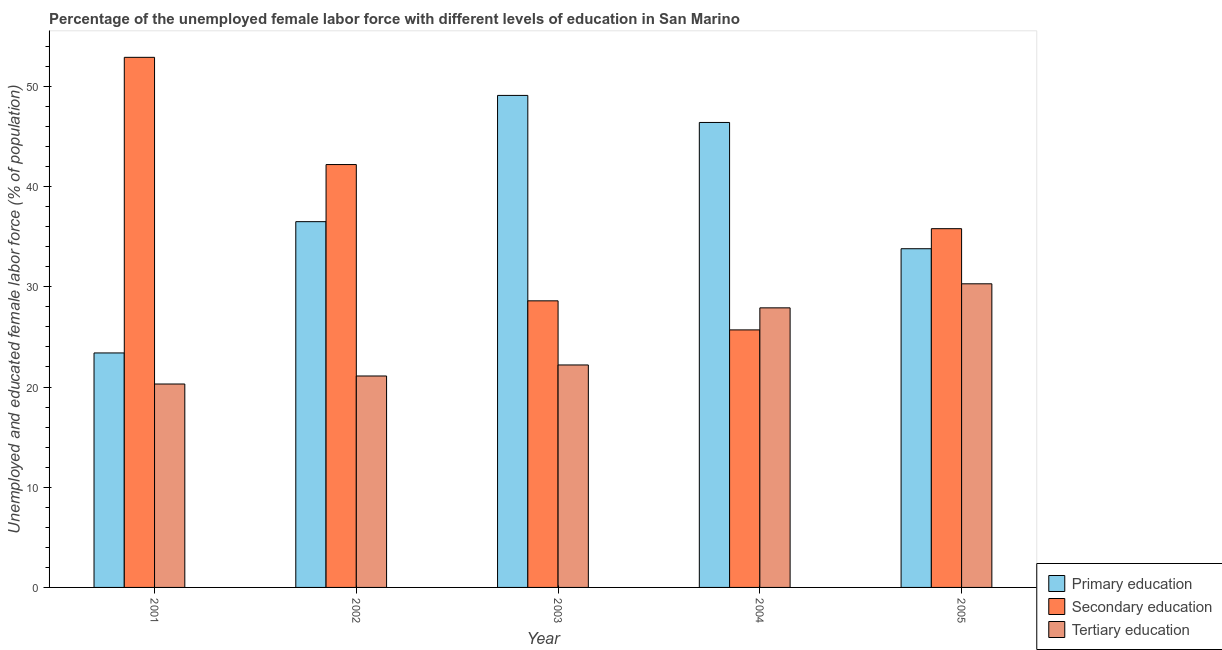How many different coloured bars are there?
Provide a short and direct response. 3. How many groups of bars are there?
Give a very brief answer. 5. Are the number of bars on each tick of the X-axis equal?
Provide a short and direct response. Yes. What is the percentage of female labor force who received tertiary education in 2001?
Keep it short and to the point. 20.3. Across all years, what is the maximum percentage of female labor force who received primary education?
Make the answer very short. 49.1. Across all years, what is the minimum percentage of female labor force who received secondary education?
Your response must be concise. 25.7. In which year was the percentage of female labor force who received tertiary education maximum?
Your response must be concise. 2005. What is the total percentage of female labor force who received primary education in the graph?
Make the answer very short. 189.2. What is the difference between the percentage of female labor force who received secondary education in 2002 and that in 2004?
Your answer should be very brief. 16.5. What is the difference between the percentage of female labor force who received secondary education in 2002 and the percentage of female labor force who received primary education in 2005?
Keep it short and to the point. 6.4. What is the average percentage of female labor force who received secondary education per year?
Offer a very short reply. 37.04. In the year 2002, what is the difference between the percentage of female labor force who received tertiary education and percentage of female labor force who received primary education?
Keep it short and to the point. 0. What is the ratio of the percentage of female labor force who received tertiary education in 2004 to that in 2005?
Offer a very short reply. 0.92. Is the percentage of female labor force who received secondary education in 2001 less than that in 2002?
Keep it short and to the point. No. Is the difference between the percentage of female labor force who received primary education in 2001 and 2003 greater than the difference between the percentage of female labor force who received tertiary education in 2001 and 2003?
Your answer should be very brief. No. What is the difference between the highest and the second highest percentage of female labor force who received tertiary education?
Keep it short and to the point. 2.4. What does the 2nd bar from the left in 2004 represents?
Make the answer very short. Secondary education. What does the 2nd bar from the right in 2004 represents?
Provide a succinct answer. Secondary education. How many bars are there?
Make the answer very short. 15. Are all the bars in the graph horizontal?
Your answer should be compact. No. How many years are there in the graph?
Offer a terse response. 5. What is the difference between two consecutive major ticks on the Y-axis?
Keep it short and to the point. 10. Are the values on the major ticks of Y-axis written in scientific E-notation?
Give a very brief answer. No. Does the graph contain any zero values?
Your answer should be very brief. No. Does the graph contain grids?
Offer a very short reply. No. How many legend labels are there?
Provide a succinct answer. 3. How are the legend labels stacked?
Your answer should be very brief. Vertical. What is the title of the graph?
Offer a very short reply. Percentage of the unemployed female labor force with different levels of education in San Marino. Does "Hydroelectric sources" appear as one of the legend labels in the graph?
Give a very brief answer. No. What is the label or title of the Y-axis?
Offer a very short reply. Unemployed and educated female labor force (% of population). What is the Unemployed and educated female labor force (% of population) of Primary education in 2001?
Provide a succinct answer. 23.4. What is the Unemployed and educated female labor force (% of population) in Secondary education in 2001?
Ensure brevity in your answer.  52.9. What is the Unemployed and educated female labor force (% of population) of Tertiary education in 2001?
Ensure brevity in your answer.  20.3. What is the Unemployed and educated female labor force (% of population) in Primary education in 2002?
Give a very brief answer. 36.5. What is the Unemployed and educated female labor force (% of population) of Secondary education in 2002?
Your response must be concise. 42.2. What is the Unemployed and educated female labor force (% of population) of Tertiary education in 2002?
Ensure brevity in your answer.  21.1. What is the Unemployed and educated female labor force (% of population) of Primary education in 2003?
Provide a succinct answer. 49.1. What is the Unemployed and educated female labor force (% of population) in Secondary education in 2003?
Your response must be concise. 28.6. What is the Unemployed and educated female labor force (% of population) of Tertiary education in 2003?
Provide a short and direct response. 22.2. What is the Unemployed and educated female labor force (% of population) of Primary education in 2004?
Your response must be concise. 46.4. What is the Unemployed and educated female labor force (% of population) in Secondary education in 2004?
Your response must be concise. 25.7. What is the Unemployed and educated female labor force (% of population) in Tertiary education in 2004?
Provide a succinct answer. 27.9. What is the Unemployed and educated female labor force (% of population) of Primary education in 2005?
Your response must be concise. 33.8. What is the Unemployed and educated female labor force (% of population) of Secondary education in 2005?
Offer a very short reply. 35.8. What is the Unemployed and educated female labor force (% of population) of Tertiary education in 2005?
Your response must be concise. 30.3. Across all years, what is the maximum Unemployed and educated female labor force (% of population) in Primary education?
Make the answer very short. 49.1. Across all years, what is the maximum Unemployed and educated female labor force (% of population) in Secondary education?
Provide a succinct answer. 52.9. Across all years, what is the maximum Unemployed and educated female labor force (% of population) of Tertiary education?
Ensure brevity in your answer.  30.3. Across all years, what is the minimum Unemployed and educated female labor force (% of population) in Primary education?
Offer a very short reply. 23.4. Across all years, what is the minimum Unemployed and educated female labor force (% of population) of Secondary education?
Ensure brevity in your answer.  25.7. Across all years, what is the minimum Unemployed and educated female labor force (% of population) in Tertiary education?
Offer a terse response. 20.3. What is the total Unemployed and educated female labor force (% of population) of Primary education in the graph?
Your answer should be compact. 189.2. What is the total Unemployed and educated female labor force (% of population) of Secondary education in the graph?
Keep it short and to the point. 185.2. What is the total Unemployed and educated female labor force (% of population) in Tertiary education in the graph?
Provide a succinct answer. 121.8. What is the difference between the Unemployed and educated female labor force (% of population) in Primary education in 2001 and that in 2003?
Your response must be concise. -25.7. What is the difference between the Unemployed and educated female labor force (% of population) in Secondary education in 2001 and that in 2003?
Give a very brief answer. 24.3. What is the difference between the Unemployed and educated female labor force (% of population) in Secondary education in 2001 and that in 2004?
Your answer should be very brief. 27.2. What is the difference between the Unemployed and educated female labor force (% of population) of Tertiary education in 2001 and that in 2004?
Provide a succinct answer. -7.6. What is the difference between the Unemployed and educated female labor force (% of population) in Primary education in 2001 and that in 2005?
Provide a succinct answer. -10.4. What is the difference between the Unemployed and educated female labor force (% of population) in Tertiary education in 2002 and that in 2003?
Provide a succinct answer. -1.1. What is the difference between the Unemployed and educated female labor force (% of population) in Primary education in 2002 and that in 2004?
Make the answer very short. -9.9. What is the difference between the Unemployed and educated female labor force (% of population) in Secondary education in 2002 and that in 2004?
Provide a short and direct response. 16.5. What is the difference between the Unemployed and educated female labor force (% of population) of Primary education in 2002 and that in 2005?
Ensure brevity in your answer.  2.7. What is the difference between the Unemployed and educated female labor force (% of population) in Secondary education in 2002 and that in 2005?
Provide a short and direct response. 6.4. What is the difference between the Unemployed and educated female labor force (% of population) of Tertiary education in 2002 and that in 2005?
Make the answer very short. -9.2. What is the difference between the Unemployed and educated female labor force (% of population) in Primary education in 2003 and that in 2004?
Keep it short and to the point. 2.7. What is the difference between the Unemployed and educated female labor force (% of population) of Tertiary education in 2003 and that in 2004?
Offer a terse response. -5.7. What is the difference between the Unemployed and educated female labor force (% of population) in Primary education in 2003 and that in 2005?
Your response must be concise. 15.3. What is the difference between the Unemployed and educated female labor force (% of population) of Tertiary education in 2004 and that in 2005?
Your response must be concise. -2.4. What is the difference between the Unemployed and educated female labor force (% of population) of Primary education in 2001 and the Unemployed and educated female labor force (% of population) of Secondary education in 2002?
Your answer should be compact. -18.8. What is the difference between the Unemployed and educated female labor force (% of population) of Secondary education in 2001 and the Unemployed and educated female labor force (% of population) of Tertiary education in 2002?
Provide a short and direct response. 31.8. What is the difference between the Unemployed and educated female labor force (% of population) in Primary education in 2001 and the Unemployed and educated female labor force (% of population) in Secondary education in 2003?
Your answer should be very brief. -5.2. What is the difference between the Unemployed and educated female labor force (% of population) of Secondary education in 2001 and the Unemployed and educated female labor force (% of population) of Tertiary education in 2003?
Ensure brevity in your answer.  30.7. What is the difference between the Unemployed and educated female labor force (% of population) in Primary education in 2001 and the Unemployed and educated female labor force (% of population) in Secondary education in 2005?
Ensure brevity in your answer.  -12.4. What is the difference between the Unemployed and educated female labor force (% of population) in Secondary education in 2001 and the Unemployed and educated female labor force (% of population) in Tertiary education in 2005?
Your answer should be very brief. 22.6. What is the difference between the Unemployed and educated female labor force (% of population) of Primary education in 2002 and the Unemployed and educated female labor force (% of population) of Tertiary education in 2004?
Your response must be concise. 8.6. What is the difference between the Unemployed and educated female labor force (% of population) of Secondary education in 2002 and the Unemployed and educated female labor force (% of population) of Tertiary education in 2004?
Your answer should be compact. 14.3. What is the difference between the Unemployed and educated female labor force (% of population) in Primary education in 2002 and the Unemployed and educated female labor force (% of population) in Secondary education in 2005?
Provide a succinct answer. 0.7. What is the difference between the Unemployed and educated female labor force (% of population) in Primary education in 2002 and the Unemployed and educated female labor force (% of population) in Tertiary education in 2005?
Your answer should be very brief. 6.2. What is the difference between the Unemployed and educated female labor force (% of population) of Secondary education in 2002 and the Unemployed and educated female labor force (% of population) of Tertiary education in 2005?
Give a very brief answer. 11.9. What is the difference between the Unemployed and educated female labor force (% of population) in Primary education in 2003 and the Unemployed and educated female labor force (% of population) in Secondary education in 2004?
Your response must be concise. 23.4. What is the difference between the Unemployed and educated female labor force (% of population) of Primary education in 2003 and the Unemployed and educated female labor force (% of population) of Tertiary education in 2004?
Your answer should be compact. 21.2. What is the difference between the Unemployed and educated female labor force (% of population) of Secondary education in 2003 and the Unemployed and educated female labor force (% of population) of Tertiary education in 2004?
Offer a terse response. 0.7. What is the difference between the Unemployed and educated female labor force (% of population) of Primary education in 2003 and the Unemployed and educated female labor force (% of population) of Secondary education in 2005?
Provide a succinct answer. 13.3. What is the difference between the Unemployed and educated female labor force (% of population) in Primary education in 2003 and the Unemployed and educated female labor force (% of population) in Tertiary education in 2005?
Provide a succinct answer. 18.8. What is the difference between the Unemployed and educated female labor force (% of population) in Primary education in 2004 and the Unemployed and educated female labor force (% of population) in Tertiary education in 2005?
Offer a terse response. 16.1. What is the difference between the Unemployed and educated female labor force (% of population) in Secondary education in 2004 and the Unemployed and educated female labor force (% of population) in Tertiary education in 2005?
Your answer should be very brief. -4.6. What is the average Unemployed and educated female labor force (% of population) in Primary education per year?
Your answer should be compact. 37.84. What is the average Unemployed and educated female labor force (% of population) in Secondary education per year?
Your answer should be very brief. 37.04. What is the average Unemployed and educated female labor force (% of population) of Tertiary education per year?
Offer a very short reply. 24.36. In the year 2001, what is the difference between the Unemployed and educated female labor force (% of population) in Primary education and Unemployed and educated female labor force (% of population) in Secondary education?
Your answer should be very brief. -29.5. In the year 2001, what is the difference between the Unemployed and educated female labor force (% of population) in Primary education and Unemployed and educated female labor force (% of population) in Tertiary education?
Give a very brief answer. 3.1. In the year 2001, what is the difference between the Unemployed and educated female labor force (% of population) of Secondary education and Unemployed and educated female labor force (% of population) of Tertiary education?
Your answer should be compact. 32.6. In the year 2002, what is the difference between the Unemployed and educated female labor force (% of population) in Primary education and Unemployed and educated female labor force (% of population) in Secondary education?
Ensure brevity in your answer.  -5.7. In the year 2002, what is the difference between the Unemployed and educated female labor force (% of population) of Primary education and Unemployed and educated female labor force (% of population) of Tertiary education?
Your answer should be very brief. 15.4. In the year 2002, what is the difference between the Unemployed and educated female labor force (% of population) in Secondary education and Unemployed and educated female labor force (% of population) in Tertiary education?
Your answer should be very brief. 21.1. In the year 2003, what is the difference between the Unemployed and educated female labor force (% of population) in Primary education and Unemployed and educated female labor force (% of population) in Tertiary education?
Your answer should be very brief. 26.9. In the year 2003, what is the difference between the Unemployed and educated female labor force (% of population) in Secondary education and Unemployed and educated female labor force (% of population) in Tertiary education?
Make the answer very short. 6.4. In the year 2004, what is the difference between the Unemployed and educated female labor force (% of population) in Primary education and Unemployed and educated female labor force (% of population) in Secondary education?
Your answer should be compact. 20.7. In the year 2004, what is the difference between the Unemployed and educated female labor force (% of population) in Secondary education and Unemployed and educated female labor force (% of population) in Tertiary education?
Keep it short and to the point. -2.2. In the year 2005, what is the difference between the Unemployed and educated female labor force (% of population) of Primary education and Unemployed and educated female labor force (% of population) of Secondary education?
Offer a terse response. -2. In the year 2005, what is the difference between the Unemployed and educated female labor force (% of population) in Secondary education and Unemployed and educated female labor force (% of population) in Tertiary education?
Give a very brief answer. 5.5. What is the ratio of the Unemployed and educated female labor force (% of population) of Primary education in 2001 to that in 2002?
Provide a succinct answer. 0.64. What is the ratio of the Unemployed and educated female labor force (% of population) of Secondary education in 2001 to that in 2002?
Your answer should be very brief. 1.25. What is the ratio of the Unemployed and educated female labor force (% of population) in Tertiary education in 2001 to that in 2002?
Make the answer very short. 0.96. What is the ratio of the Unemployed and educated female labor force (% of population) in Primary education in 2001 to that in 2003?
Ensure brevity in your answer.  0.48. What is the ratio of the Unemployed and educated female labor force (% of population) in Secondary education in 2001 to that in 2003?
Offer a very short reply. 1.85. What is the ratio of the Unemployed and educated female labor force (% of population) of Tertiary education in 2001 to that in 2003?
Make the answer very short. 0.91. What is the ratio of the Unemployed and educated female labor force (% of population) of Primary education in 2001 to that in 2004?
Ensure brevity in your answer.  0.5. What is the ratio of the Unemployed and educated female labor force (% of population) in Secondary education in 2001 to that in 2004?
Offer a terse response. 2.06. What is the ratio of the Unemployed and educated female labor force (% of population) of Tertiary education in 2001 to that in 2004?
Provide a succinct answer. 0.73. What is the ratio of the Unemployed and educated female labor force (% of population) in Primary education in 2001 to that in 2005?
Give a very brief answer. 0.69. What is the ratio of the Unemployed and educated female labor force (% of population) of Secondary education in 2001 to that in 2005?
Ensure brevity in your answer.  1.48. What is the ratio of the Unemployed and educated female labor force (% of population) of Tertiary education in 2001 to that in 2005?
Keep it short and to the point. 0.67. What is the ratio of the Unemployed and educated female labor force (% of population) of Primary education in 2002 to that in 2003?
Your answer should be compact. 0.74. What is the ratio of the Unemployed and educated female labor force (% of population) in Secondary education in 2002 to that in 2003?
Provide a short and direct response. 1.48. What is the ratio of the Unemployed and educated female labor force (% of population) in Tertiary education in 2002 to that in 2003?
Your answer should be very brief. 0.95. What is the ratio of the Unemployed and educated female labor force (% of population) of Primary education in 2002 to that in 2004?
Your answer should be compact. 0.79. What is the ratio of the Unemployed and educated female labor force (% of population) of Secondary education in 2002 to that in 2004?
Offer a terse response. 1.64. What is the ratio of the Unemployed and educated female labor force (% of population) of Tertiary education in 2002 to that in 2004?
Offer a terse response. 0.76. What is the ratio of the Unemployed and educated female labor force (% of population) in Primary education in 2002 to that in 2005?
Provide a succinct answer. 1.08. What is the ratio of the Unemployed and educated female labor force (% of population) of Secondary education in 2002 to that in 2005?
Your answer should be compact. 1.18. What is the ratio of the Unemployed and educated female labor force (% of population) in Tertiary education in 2002 to that in 2005?
Ensure brevity in your answer.  0.7. What is the ratio of the Unemployed and educated female labor force (% of population) of Primary education in 2003 to that in 2004?
Ensure brevity in your answer.  1.06. What is the ratio of the Unemployed and educated female labor force (% of population) in Secondary education in 2003 to that in 2004?
Provide a succinct answer. 1.11. What is the ratio of the Unemployed and educated female labor force (% of population) of Tertiary education in 2003 to that in 2004?
Your answer should be compact. 0.8. What is the ratio of the Unemployed and educated female labor force (% of population) in Primary education in 2003 to that in 2005?
Give a very brief answer. 1.45. What is the ratio of the Unemployed and educated female labor force (% of population) in Secondary education in 2003 to that in 2005?
Offer a very short reply. 0.8. What is the ratio of the Unemployed and educated female labor force (% of population) of Tertiary education in 2003 to that in 2005?
Provide a short and direct response. 0.73. What is the ratio of the Unemployed and educated female labor force (% of population) in Primary education in 2004 to that in 2005?
Make the answer very short. 1.37. What is the ratio of the Unemployed and educated female labor force (% of population) in Secondary education in 2004 to that in 2005?
Provide a short and direct response. 0.72. What is the ratio of the Unemployed and educated female labor force (% of population) in Tertiary education in 2004 to that in 2005?
Your answer should be very brief. 0.92. What is the difference between the highest and the second highest Unemployed and educated female labor force (% of population) in Primary education?
Offer a terse response. 2.7. What is the difference between the highest and the second highest Unemployed and educated female labor force (% of population) of Tertiary education?
Give a very brief answer. 2.4. What is the difference between the highest and the lowest Unemployed and educated female labor force (% of population) of Primary education?
Your answer should be very brief. 25.7. What is the difference between the highest and the lowest Unemployed and educated female labor force (% of population) of Secondary education?
Your answer should be compact. 27.2. What is the difference between the highest and the lowest Unemployed and educated female labor force (% of population) of Tertiary education?
Provide a short and direct response. 10. 